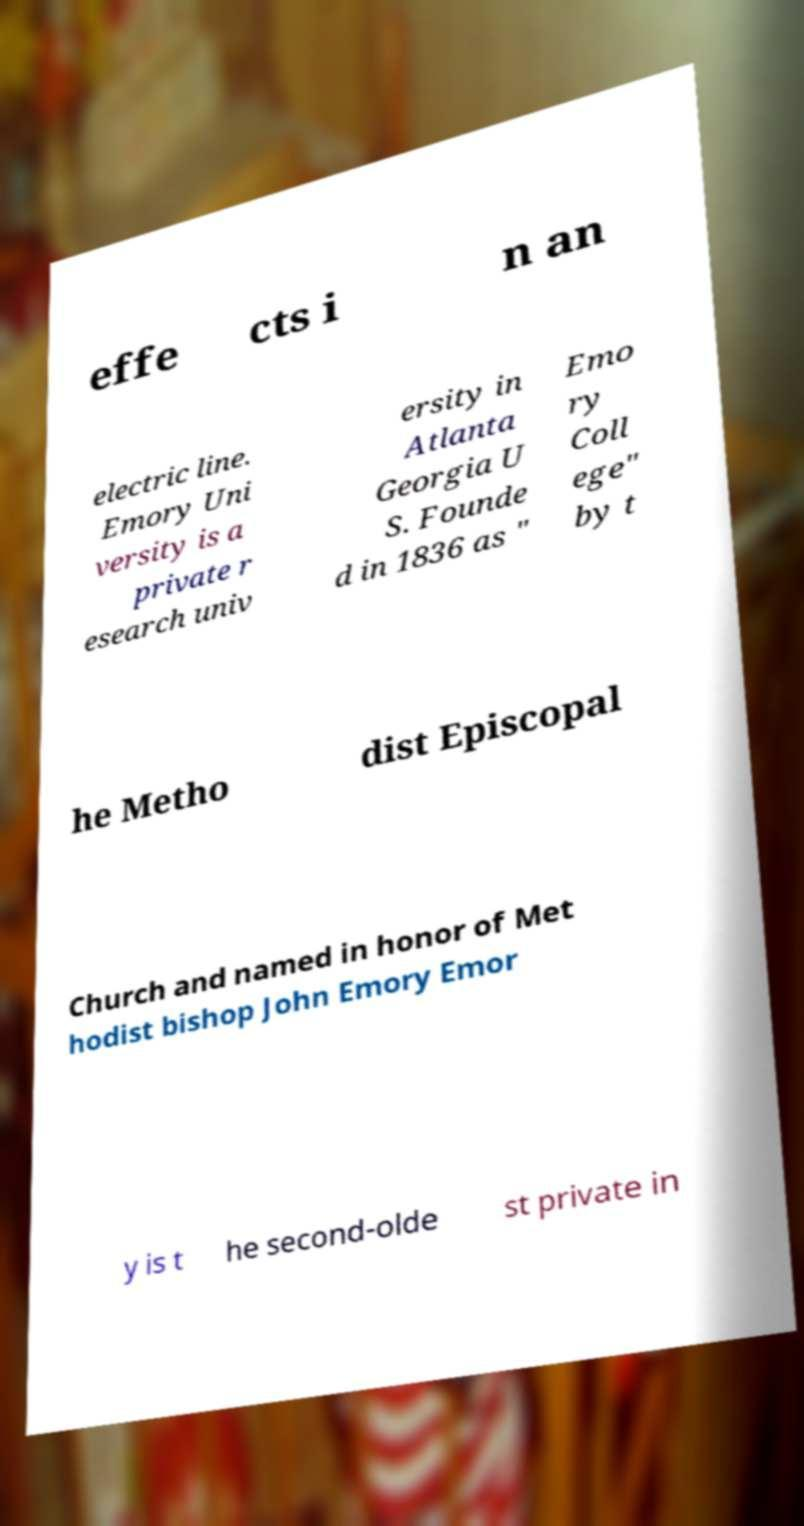What messages or text are displayed in this image? I need them in a readable, typed format. effe cts i n an electric line. Emory Uni versity is a private r esearch univ ersity in Atlanta Georgia U S. Founde d in 1836 as " Emo ry Coll ege" by t he Metho dist Episcopal Church and named in honor of Met hodist bishop John Emory Emor y is t he second-olde st private in 